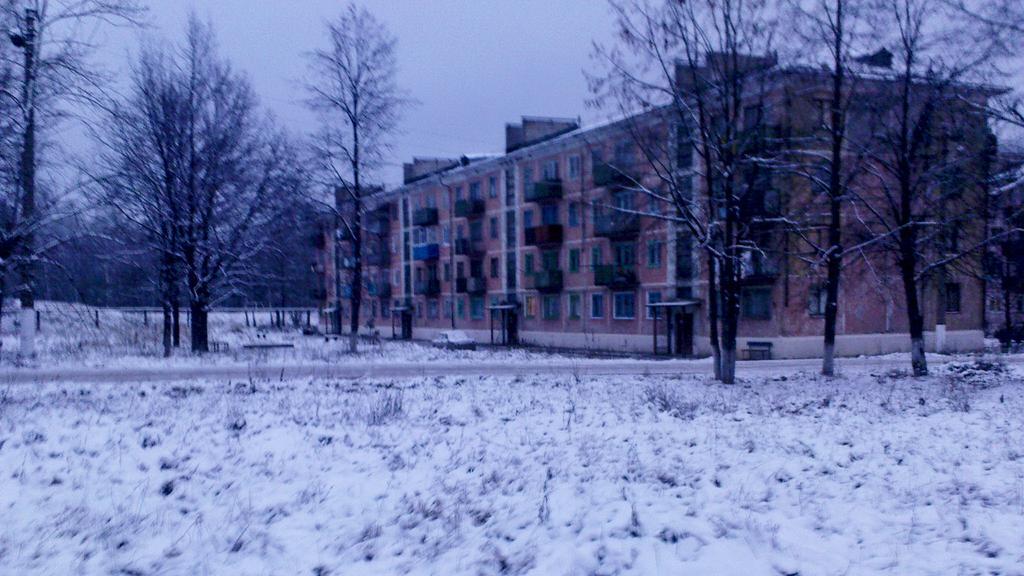How would you summarize this image in a sentence or two? This image consists of a building. In the front, there are many trees. At the bottom, there is snow on the ground. 